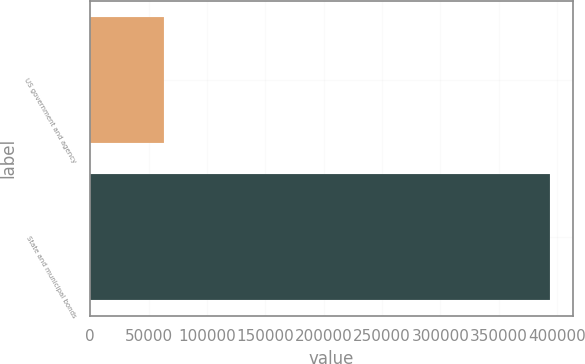<chart> <loc_0><loc_0><loc_500><loc_500><bar_chart><fcel>US government and agency<fcel>State and municipal bonds<nl><fcel>63042<fcel>393760<nl></chart> 